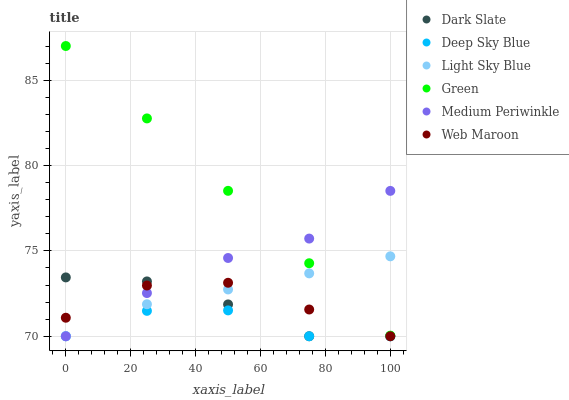Does Deep Sky Blue have the minimum area under the curve?
Answer yes or no. Yes. Does Green have the maximum area under the curve?
Answer yes or no. Yes. Does Web Maroon have the minimum area under the curve?
Answer yes or no. No. Does Web Maroon have the maximum area under the curve?
Answer yes or no. No. Is Green the smoothest?
Answer yes or no. Yes. Is Deep Sky Blue the roughest?
Answer yes or no. Yes. Is Web Maroon the smoothest?
Answer yes or no. No. Is Web Maroon the roughest?
Answer yes or no. No. Does Medium Periwinkle have the lowest value?
Answer yes or no. Yes. Does Green have the lowest value?
Answer yes or no. No. Does Green have the highest value?
Answer yes or no. Yes. Does Web Maroon have the highest value?
Answer yes or no. No. Is Dark Slate less than Green?
Answer yes or no. Yes. Is Green greater than Deep Sky Blue?
Answer yes or no. Yes. Does Medium Periwinkle intersect Dark Slate?
Answer yes or no. Yes. Is Medium Periwinkle less than Dark Slate?
Answer yes or no. No. Is Medium Periwinkle greater than Dark Slate?
Answer yes or no. No. Does Dark Slate intersect Green?
Answer yes or no. No. 